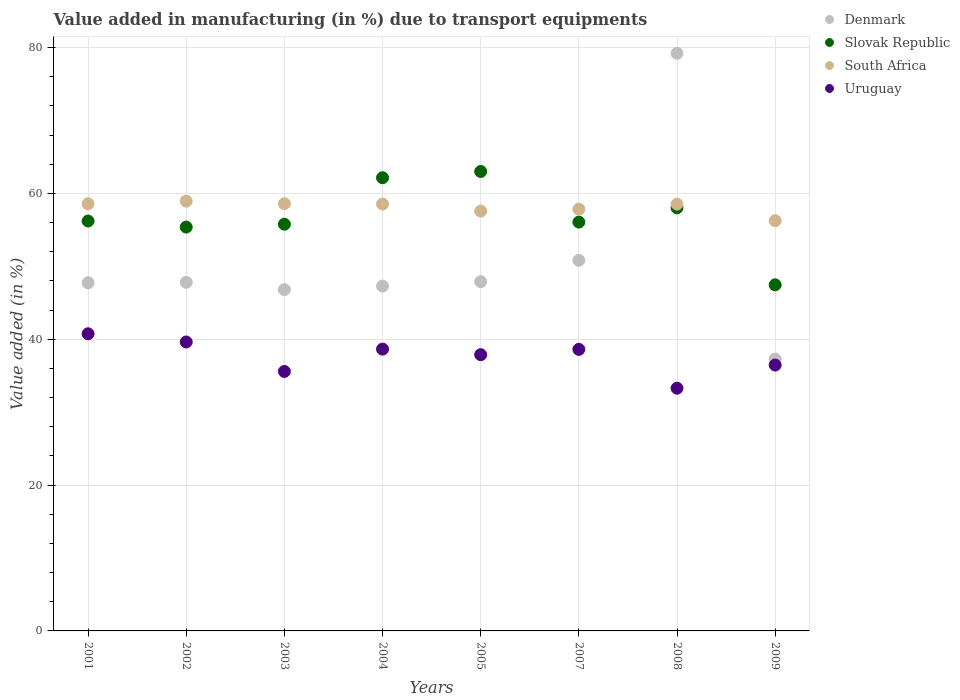What is the percentage of value added in manufacturing due to transport equipments in Denmark in 2007?
Ensure brevity in your answer.  50.82. Across all years, what is the maximum percentage of value added in manufacturing due to transport equipments in Uruguay?
Make the answer very short. 40.75. Across all years, what is the minimum percentage of value added in manufacturing due to transport equipments in South Africa?
Your answer should be compact. 56.25. What is the total percentage of value added in manufacturing due to transport equipments in South Africa in the graph?
Give a very brief answer. 464.84. What is the difference between the percentage of value added in manufacturing due to transport equipments in South Africa in 2005 and that in 2007?
Keep it short and to the point. -0.28. What is the difference between the percentage of value added in manufacturing due to transport equipments in South Africa in 2004 and the percentage of value added in manufacturing due to transport equipments in Uruguay in 2005?
Offer a terse response. 20.66. What is the average percentage of value added in manufacturing due to transport equipments in Denmark per year?
Give a very brief answer. 50.6. In the year 2004, what is the difference between the percentage of value added in manufacturing due to transport equipments in South Africa and percentage of value added in manufacturing due to transport equipments in Uruguay?
Provide a short and direct response. 19.9. What is the ratio of the percentage of value added in manufacturing due to transport equipments in Uruguay in 2008 to that in 2009?
Your response must be concise. 0.91. What is the difference between the highest and the second highest percentage of value added in manufacturing due to transport equipments in Denmark?
Give a very brief answer. 28.39. What is the difference between the highest and the lowest percentage of value added in manufacturing due to transport equipments in South Africa?
Provide a succinct answer. 2.68. Is the sum of the percentage of value added in manufacturing due to transport equipments in Uruguay in 2001 and 2002 greater than the maximum percentage of value added in manufacturing due to transport equipments in Slovak Republic across all years?
Your answer should be compact. Yes. Is it the case that in every year, the sum of the percentage of value added in manufacturing due to transport equipments in Uruguay and percentage of value added in manufacturing due to transport equipments in Denmark  is greater than the percentage of value added in manufacturing due to transport equipments in Slovak Republic?
Make the answer very short. Yes. Does the percentage of value added in manufacturing due to transport equipments in Slovak Republic monotonically increase over the years?
Your response must be concise. No. Is the percentage of value added in manufacturing due to transport equipments in Denmark strictly greater than the percentage of value added in manufacturing due to transport equipments in Slovak Republic over the years?
Make the answer very short. No. Is the percentage of value added in manufacturing due to transport equipments in Slovak Republic strictly less than the percentage of value added in manufacturing due to transport equipments in South Africa over the years?
Make the answer very short. No. How many years are there in the graph?
Offer a terse response. 8. What is the difference between two consecutive major ticks on the Y-axis?
Offer a very short reply. 20. Are the values on the major ticks of Y-axis written in scientific E-notation?
Provide a short and direct response. No. Does the graph contain any zero values?
Your answer should be very brief. No. How many legend labels are there?
Your response must be concise. 4. How are the legend labels stacked?
Your answer should be compact. Vertical. What is the title of the graph?
Your answer should be compact. Value added in manufacturing (in %) due to transport equipments. What is the label or title of the Y-axis?
Your answer should be very brief. Value added (in %). What is the Value added (in %) of Denmark in 2001?
Ensure brevity in your answer.  47.74. What is the Value added (in %) in Slovak Republic in 2001?
Ensure brevity in your answer.  56.21. What is the Value added (in %) of South Africa in 2001?
Your answer should be compact. 58.58. What is the Value added (in %) of Uruguay in 2001?
Your answer should be very brief. 40.75. What is the Value added (in %) of Denmark in 2002?
Give a very brief answer. 47.8. What is the Value added (in %) in Slovak Republic in 2002?
Provide a short and direct response. 55.38. What is the Value added (in %) in South Africa in 2002?
Your response must be concise. 58.93. What is the Value added (in %) of Uruguay in 2002?
Provide a short and direct response. 39.62. What is the Value added (in %) in Denmark in 2003?
Your answer should be compact. 46.8. What is the Value added (in %) of Slovak Republic in 2003?
Keep it short and to the point. 55.77. What is the Value added (in %) of South Africa in 2003?
Your answer should be compact. 58.59. What is the Value added (in %) in Uruguay in 2003?
Give a very brief answer. 35.58. What is the Value added (in %) of Denmark in 2004?
Offer a terse response. 47.29. What is the Value added (in %) in Slovak Republic in 2004?
Keep it short and to the point. 62.15. What is the Value added (in %) of South Africa in 2004?
Make the answer very short. 58.54. What is the Value added (in %) of Uruguay in 2004?
Your answer should be compact. 38.64. What is the Value added (in %) of Denmark in 2005?
Keep it short and to the point. 47.89. What is the Value added (in %) in Slovak Republic in 2005?
Offer a terse response. 63. What is the Value added (in %) of South Africa in 2005?
Keep it short and to the point. 57.57. What is the Value added (in %) in Uruguay in 2005?
Offer a very short reply. 37.88. What is the Value added (in %) in Denmark in 2007?
Ensure brevity in your answer.  50.82. What is the Value added (in %) of Slovak Republic in 2007?
Your answer should be compact. 56.06. What is the Value added (in %) of South Africa in 2007?
Ensure brevity in your answer.  57.85. What is the Value added (in %) in Uruguay in 2007?
Provide a short and direct response. 38.61. What is the Value added (in %) of Denmark in 2008?
Your answer should be very brief. 79.21. What is the Value added (in %) in Slovak Republic in 2008?
Offer a terse response. 58.01. What is the Value added (in %) in South Africa in 2008?
Your answer should be compact. 58.53. What is the Value added (in %) in Uruguay in 2008?
Provide a succinct answer. 33.28. What is the Value added (in %) in Denmark in 2009?
Your answer should be compact. 37.28. What is the Value added (in %) of Slovak Republic in 2009?
Offer a terse response. 47.46. What is the Value added (in %) of South Africa in 2009?
Your answer should be compact. 56.25. What is the Value added (in %) in Uruguay in 2009?
Ensure brevity in your answer.  36.46. Across all years, what is the maximum Value added (in %) of Denmark?
Offer a terse response. 79.21. Across all years, what is the maximum Value added (in %) in Slovak Republic?
Your response must be concise. 63. Across all years, what is the maximum Value added (in %) of South Africa?
Your answer should be very brief. 58.93. Across all years, what is the maximum Value added (in %) in Uruguay?
Your answer should be very brief. 40.75. Across all years, what is the minimum Value added (in %) of Denmark?
Make the answer very short. 37.28. Across all years, what is the minimum Value added (in %) of Slovak Republic?
Your answer should be compact. 47.46. Across all years, what is the minimum Value added (in %) in South Africa?
Ensure brevity in your answer.  56.25. Across all years, what is the minimum Value added (in %) of Uruguay?
Provide a short and direct response. 33.28. What is the total Value added (in %) of Denmark in the graph?
Make the answer very short. 404.83. What is the total Value added (in %) of Slovak Republic in the graph?
Ensure brevity in your answer.  454.04. What is the total Value added (in %) of South Africa in the graph?
Keep it short and to the point. 464.84. What is the total Value added (in %) in Uruguay in the graph?
Ensure brevity in your answer.  300.82. What is the difference between the Value added (in %) of Denmark in 2001 and that in 2002?
Ensure brevity in your answer.  -0.06. What is the difference between the Value added (in %) in Slovak Republic in 2001 and that in 2002?
Offer a terse response. 0.83. What is the difference between the Value added (in %) in South Africa in 2001 and that in 2002?
Your response must be concise. -0.35. What is the difference between the Value added (in %) in Uruguay in 2001 and that in 2002?
Your answer should be very brief. 1.12. What is the difference between the Value added (in %) of Denmark in 2001 and that in 2003?
Provide a short and direct response. 0.94. What is the difference between the Value added (in %) of Slovak Republic in 2001 and that in 2003?
Offer a terse response. 0.44. What is the difference between the Value added (in %) in South Africa in 2001 and that in 2003?
Keep it short and to the point. -0. What is the difference between the Value added (in %) of Uruguay in 2001 and that in 2003?
Make the answer very short. 5.16. What is the difference between the Value added (in %) in Denmark in 2001 and that in 2004?
Ensure brevity in your answer.  0.45. What is the difference between the Value added (in %) in Slovak Republic in 2001 and that in 2004?
Keep it short and to the point. -5.94. What is the difference between the Value added (in %) in South Africa in 2001 and that in 2004?
Provide a short and direct response. 0.04. What is the difference between the Value added (in %) in Uruguay in 2001 and that in 2004?
Give a very brief answer. 2.1. What is the difference between the Value added (in %) of Denmark in 2001 and that in 2005?
Keep it short and to the point. -0.15. What is the difference between the Value added (in %) in Slovak Republic in 2001 and that in 2005?
Provide a succinct answer. -6.79. What is the difference between the Value added (in %) in South Africa in 2001 and that in 2005?
Give a very brief answer. 1.01. What is the difference between the Value added (in %) of Uruguay in 2001 and that in 2005?
Offer a terse response. 2.87. What is the difference between the Value added (in %) in Denmark in 2001 and that in 2007?
Offer a very short reply. -3.08. What is the difference between the Value added (in %) in Slovak Republic in 2001 and that in 2007?
Give a very brief answer. 0.15. What is the difference between the Value added (in %) of South Africa in 2001 and that in 2007?
Your response must be concise. 0.74. What is the difference between the Value added (in %) in Uruguay in 2001 and that in 2007?
Give a very brief answer. 2.14. What is the difference between the Value added (in %) in Denmark in 2001 and that in 2008?
Keep it short and to the point. -31.46. What is the difference between the Value added (in %) of Slovak Republic in 2001 and that in 2008?
Offer a terse response. -1.8. What is the difference between the Value added (in %) of South Africa in 2001 and that in 2008?
Offer a very short reply. 0.05. What is the difference between the Value added (in %) in Uruguay in 2001 and that in 2008?
Your answer should be very brief. 7.46. What is the difference between the Value added (in %) of Denmark in 2001 and that in 2009?
Offer a terse response. 10.46. What is the difference between the Value added (in %) of Slovak Republic in 2001 and that in 2009?
Provide a succinct answer. 8.75. What is the difference between the Value added (in %) in South Africa in 2001 and that in 2009?
Make the answer very short. 2.33. What is the difference between the Value added (in %) in Uruguay in 2001 and that in 2009?
Your response must be concise. 4.29. What is the difference between the Value added (in %) of Slovak Republic in 2002 and that in 2003?
Provide a succinct answer. -0.4. What is the difference between the Value added (in %) of South Africa in 2002 and that in 2003?
Your response must be concise. 0.35. What is the difference between the Value added (in %) in Uruguay in 2002 and that in 2003?
Provide a succinct answer. 4.04. What is the difference between the Value added (in %) of Denmark in 2002 and that in 2004?
Offer a terse response. 0.51. What is the difference between the Value added (in %) in Slovak Republic in 2002 and that in 2004?
Your answer should be very brief. -6.77. What is the difference between the Value added (in %) in South Africa in 2002 and that in 2004?
Your answer should be very brief. 0.39. What is the difference between the Value added (in %) of Uruguay in 2002 and that in 2004?
Keep it short and to the point. 0.98. What is the difference between the Value added (in %) of Denmark in 2002 and that in 2005?
Your answer should be very brief. -0.09. What is the difference between the Value added (in %) in Slovak Republic in 2002 and that in 2005?
Offer a terse response. -7.63. What is the difference between the Value added (in %) of South Africa in 2002 and that in 2005?
Offer a terse response. 1.36. What is the difference between the Value added (in %) of Uruguay in 2002 and that in 2005?
Provide a short and direct response. 1.74. What is the difference between the Value added (in %) of Denmark in 2002 and that in 2007?
Offer a very short reply. -3.02. What is the difference between the Value added (in %) of Slovak Republic in 2002 and that in 2007?
Your response must be concise. -0.69. What is the difference between the Value added (in %) in South Africa in 2002 and that in 2007?
Make the answer very short. 1.09. What is the difference between the Value added (in %) in Uruguay in 2002 and that in 2007?
Offer a terse response. 1.01. What is the difference between the Value added (in %) of Denmark in 2002 and that in 2008?
Provide a succinct answer. -31.4. What is the difference between the Value added (in %) in Slovak Republic in 2002 and that in 2008?
Provide a succinct answer. -2.64. What is the difference between the Value added (in %) in South Africa in 2002 and that in 2008?
Make the answer very short. 0.4. What is the difference between the Value added (in %) in Uruguay in 2002 and that in 2008?
Your response must be concise. 6.34. What is the difference between the Value added (in %) of Denmark in 2002 and that in 2009?
Provide a succinct answer. 10.52. What is the difference between the Value added (in %) in Slovak Republic in 2002 and that in 2009?
Your answer should be very brief. 7.92. What is the difference between the Value added (in %) in South Africa in 2002 and that in 2009?
Provide a short and direct response. 2.68. What is the difference between the Value added (in %) of Uruguay in 2002 and that in 2009?
Give a very brief answer. 3.17. What is the difference between the Value added (in %) of Denmark in 2003 and that in 2004?
Give a very brief answer. -0.49. What is the difference between the Value added (in %) in Slovak Republic in 2003 and that in 2004?
Offer a terse response. -6.37. What is the difference between the Value added (in %) of South Africa in 2003 and that in 2004?
Offer a terse response. 0.05. What is the difference between the Value added (in %) of Uruguay in 2003 and that in 2004?
Keep it short and to the point. -3.06. What is the difference between the Value added (in %) in Denmark in 2003 and that in 2005?
Your answer should be very brief. -1.09. What is the difference between the Value added (in %) in Slovak Republic in 2003 and that in 2005?
Your response must be concise. -7.23. What is the difference between the Value added (in %) of South Africa in 2003 and that in 2005?
Your answer should be compact. 1.02. What is the difference between the Value added (in %) of Uruguay in 2003 and that in 2005?
Keep it short and to the point. -2.3. What is the difference between the Value added (in %) in Denmark in 2003 and that in 2007?
Your answer should be compact. -4.02. What is the difference between the Value added (in %) of Slovak Republic in 2003 and that in 2007?
Your response must be concise. -0.29. What is the difference between the Value added (in %) in South Africa in 2003 and that in 2007?
Provide a succinct answer. 0.74. What is the difference between the Value added (in %) in Uruguay in 2003 and that in 2007?
Your answer should be very brief. -3.03. What is the difference between the Value added (in %) in Denmark in 2003 and that in 2008?
Make the answer very short. -32.4. What is the difference between the Value added (in %) of Slovak Republic in 2003 and that in 2008?
Make the answer very short. -2.24. What is the difference between the Value added (in %) in South Africa in 2003 and that in 2008?
Make the answer very short. 0.06. What is the difference between the Value added (in %) in Uruguay in 2003 and that in 2008?
Provide a short and direct response. 2.3. What is the difference between the Value added (in %) of Denmark in 2003 and that in 2009?
Make the answer very short. 9.52. What is the difference between the Value added (in %) of Slovak Republic in 2003 and that in 2009?
Your answer should be very brief. 8.31. What is the difference between the Value added (in %) of South Africa in 2003 and that in 2009?
Provide a short and direct response. 2.33. What is the difference between the Value added (in %) of Uruguay in 2003 and that in 2009?
Give a very brief answer. -0.87. What is the difference between the Value added (in %) in Denmark in 2004 and that in 2005?
Give a very brief answer. -0.6. What is the difference between the Value added (in %) in Slovak Republic in 2004 and that in 2005?
Give a very brief answer. -0.86. What is the difference between the Value added (in %) in South Africa in 2004 and that in 2005?
Provide a short and direct response. 0.97. What is the difference between the Value added (in %) of Uruguay in 2004 and that in 2005?
Your response must be concise. 0.76. What is the difference between the Value added (in %) of Denmark in 2004 and that in 2007?
Ensure brevity in your answer.  -3.53. What is the difference between the Value added (in %) of Slovak Republic in 2004 and that in 2007?
Keep it short and to the point. 6.08. What is the difference between the Value added (in %) of South Africa in 2004 and that in 2007?
Your answer should be very brief. 0.69. What is the difference between the Value added (in %) in Uruguay in 2004 and that in 2007?
Make the answer very short. 0.03. What is the difference between the Value added (in %) in Denmark in 2004 and that in 2008?
Your answer should be very brief. -31.92. What is the difference between the Value added (in %) in Slovak Republic in 2004 and that in 2008?
Provide a succinct answer. 4.13. What is the difference between the Value added (in %) of South Africa in 2004 and that in 2008?
Ensure brevity in your answer.  0.01. What is the difference between the Value added (in %) of Uruguay in 2004 and that in 2008?
Make the answer very short. 5.36. What is the difference between the Value added (in %) of Denmark in 2004 and that in 2009?
Your answer should be very brief. 10.01. What is the difference between the Value added (in %) in Slovak Republic in 2004 and that in 2009?
Your answer should be compact. 14.69. What is the difference between the Value added (in %) of South Africa in 2004 and that in 2009?
Make the answer very short. 2.29. What is the difference between the Value added (in %) of Uruguay in 2004 and that in 2009?
Ensure brevity in your answer.  2.19. What is the difference between the Value added (in %) of Denmark in 2005 and that in 2007?
Make the answer very short. -2.93. What is the difference between the Value added (in %) of Slovak Republic in 2005 and that in 2007?
Provide a short and direct response. 6.94. What is the difference between the Value added (in %) in South Africa in 2005 and that in 2007?
Provide a succinct answer. -0.28. What is the difference between the Value added (in %) in Uruguay in 2005 and that in 2007?
Your answer should be compact. -0.73. What is the difference between the Value added (in %) of Denmark in 2005 and that in 2008?
Offer a very short reply. -31.31. What is the difference between the Value added (in %) in Slovak Republic in 2005 and that in 2008?
Your response must be concise. 4.99. What is the difference between the Value added (in %) of South Africa in 2005 and that in 2008?
Ensure brevity in your answer.  -0.96. What is the difference between the Value added (in %) of Uruguay in 2005 and that in 2008?
Offer a terse response. 4.6. What is the difference between the Value added (in %) in Denmark in 2005 and that in 2009?
Offer a terse response. 10.61. What is the difference between the Value added (in %) in Slovak Republic in 2005 and that in 2009?
Ensure brevity in your answer.  15.54. What is the difference between the Value added (in %) in South Africa in 2005 and that in 2009?
Ensure brevity in your answer.  1.31. What is the difference between the Value added (in %) in Uruguay in 2005 and that in 2009?
Make the answer very short. 1.42. What is the difference between the Value added (in %) in Denmark in 2007 and that in 2008?
Your response must be concise. -28.39. What is the difference between the Value added (in %) in Slovak Republic in 2007 and that in 2008?
Make the answer very short. -1.95. What is the difference between the Value added (in %) in South Africa in 2007 and that in 2008?
Offer a very short reply. -0.68. What is the difference between the Value added (in %) in Uruguay in 2007 and that in 2008?
Offer a terse response. 5.33. What is the difference between the Value added (in %) of Denmark in 2007 and that in 2009?
Keep it short and to the point. 13.54. What is the difference between the Value added (in %) of Slovak Republic in 2007 and that in 2009?
Keep it short and to the point. 8.6. What is the difference between the Value added (in %) of South Africa in 2007 and that in 2009?
Offer a very short reply. 1.59. What is the difference between the Value added (in %) in Uruguay in 2007 and that in 2009?
Offer a very short reply. 2.15. What is the difference between the Value added (in %) in Denmark in 2008 and that in 2009?
Ensure brevity in your answer.  41.93. What is the difference between the Value added (in %) of Slovak Republic in 2008 and that in 2009?
Your response must be concise. 10.55. What is the difference between the Value added (in %) of South Africa in 2008 and that in 2009?
Provide a succinct answer. 2.28. What is the difference between the Value added (in %) in Uruguay in 2008 and that in 2009?
Your answer should be very brief. -3.17. What is the difference between the Value added (in %) of Denmark in 2001 and the Value added (in %) of Slovak Republic in 2002?
Provide a succinct answer. -7.63. What is the difference between the Value added (in %) in Denmark in 2001 and the Value added (in %) in South Africa in 2002?
Make the answer very short. -11.19. What is the difference between the Value added (in %) of Denmark in 2001 and the Value added (in %) of Uruguay in 2002?
Provide a succinct answer. 8.12. What is the difference between the Value added (in %) of Slovak Republic in 2001 and the Value added (in %) of South Africa in 2002?
Ensure brevity in your answer.  -2.72. What is the difference between the Value added (in %) in Slovak Republic in 2001 and the Value added (in %) in Uruguay in 2002?
Make the answer very short. 16.59. What is the difference between the Value added (in %) in South Africa in 2001 and the Value added (in %) in Uruguay in 2002?
Keep it short and to the point. 18.96. What is the difference between the Value added (in %) of Denmark in 2001 and the Value added (in %) of Slovak Republic in 2003?
Offer a very short reply. -8.03. What is the difference between the Value added (in %) in Denmark in 2001 and the Value added (in %) in South Africa in 2003?
Make the answer very short. -10.84. What is the difference between the Value added (in %) in Denmark in 2001 and the Value added (in %) in Uruguay in 2003?
Make the answer very short. 12.16. What is the difference between the Value added (in %) of Slovak Republic in 2001 and the Value added (in %) of South Africa in 2003?
Keep it short and to the point. -2.38. What is the difference between the Value added (in %) in Slovak Republic in 2001 and the Value added (in %) in Uruguay in 2003?
Your answer should be very brief. 20.63. What is the difference between the Value added (in %) of South Africa in 2001 and the Value added (in %) of Uruguay in 2003?
Keep it short and to the point. 23. What is the difference between the Value added (in %) of Denmark in 2001 and the Value added (in %) of Slovak Republic in 2004?
Give a very brief answer. -14.4. What is the difference between the Value added (in %) of Denmark in 2001 and the Value added (in %) of South Africa in 2004?
Your answer should be very brief. -10.8. What is the difference between the Value added (in %) of Denmark in 2001 and the Value added (in %) of Uruguay in 2004?
Keep it short and to the point. 9.1. What is the difference between the Value added (in %) in Slovak Republic in 2001 and the Value added (in %) in South Africa in 2004?
Keep it short and to the point. -2.33. What is the difference between the Value added (in %) in Slovak Republic in 2001 and the Value added (in %) in Uruguay in 2004?
Your answer should be compact. 17.57. What is the difference between the Value added (in %) in South Africa in 2001 and the Value added (in %) in Uruguay in 2004?
Offer a terse response. 19.94. What is the difference between the Value added (in %) of Denmark in 2001 and the Value added (in %) of Slovak Republic in 2005?
Make the answer very short. -15.26. What is the difference between the Value added (in %) in Denmark in 2001 and the Value added (in %) in South Africa in 2005?
Keep it short and to the point. -9.83. What is the difference between the Value added (in %) in Denmark in 2001 and the Value added (in %) in Uruguay in 2005?
Make the answer very short. 9.86. What is the difference between the Value added (in %) in Slovak Republic in 2001 and the Value added (in %) in South Africa in 2005?
Give a very brief answer. -1.36. What is the difference between the Value added (in %) of Slovak Republic in 2001 and the Value added (in %) of Uruguay in 2005?
Offer a very short reply. 18.33. What is the difference between the Value added (in %) of South Africa in 2001 and the Value added (in %) of Uruguay in 2005?
Make the answer very short. 20.7. What is the difference between the Value added (in %) of Denmark in 2001 and the Value added (in %) of Slovak Republic in 2007?
Give a very brief answer. -8.32. What is the difference between the Value added (in %) of Denmark in 2001 and the Value added (in %) of South Africa in 2007?
Give a very brief answer. -10.1. What is the difference between the Value added (in %) of Denmark in 2001 and the Value added (in %) of Uruguay in 2007?
Provide a short and direct response. 9.13. What is the difference between the Value added (in %) of Slovak Republic in 2001 and the Value added (in %) of South Africa in 2007?
Your response must be concise. -1.64. What is the difference between the Value added (in %) of Slovak Republic in 2001 and the Value added (in %) of Uruguay in 2007?
Ensure brevity in your answer.  17.6. What is the difference between the Value added (in %) of South Africa in 2001 and the Value added (in %) of Uruguay in 2007?
Make the answer very short. 19.97. What is the difference between the Value added (in %) in Denmark in 2001 and the Value added (in %) in Slovak Republic in 2008?
Provide a succinct answer. -10.27. What is the difference between the Value added (in %) in Denmark in 2001 and the Value added (in %) in South Africa in 2008?
Keep it short and to the point. -10.79. What is the difference between the Value added (in %) of Denmark in 2001 and the Value added (in %) of Uruguay in 2008?
Keep it short and to the point. 14.46. What is the difference between the Value added (in %) in Slovak Republic in 2001 and the Value added (in %) in South Africa in 2008?
Provide a succinct answer. -2.32. What is the difference between the Value added (in %) of Slovak Republic in 2001 and the Value added (in %) of Uruguay in 2008?
Ensure brevity in your answer.  22.93. What is the difference between the Value added (in %) of South Africa in 2001 and the Value added (in %) of Uruguay in 2008?
Make the answer very short. 25.3. What is the difference between the Value added (in %) in Denmark in 2001 and the Value added (in %) in Slovak Republic in 2009?
Make the answer very short. 0.28. What is the difference between the Value added (in %) of Denmark in 2001 and the Value added (in %) of South Africa in 2009?
Ensure brevity in your answer.  -8.51. What is the difference between the Value added (in %) of Denmark in 2001 and the Value added (in %) of Uruguay in 2009?
Make the answer very short. 11.29. What is the difference between the Value added (in %) in Slovak Republic in 2001 and the Value added (in %) in South Africa in 2009?
Provide a short and direct response. -0.05. What is the difference between the Value added (in %) in Slovak Republic in 2001 and the Value added (in %) in Uruguay in 2009?
Your response must be concise. 19.75. What is the difference between the Value added (in %) in South Africa in 2001 and the Value added (in %) in Uruguay in 2009?
Offer a very short reply. 22.13. What is the difference between the Value added (in %) of Denmark in 2002 and the Value added (in %) of Slovak Republic in 2003?
Provide a short and direct response. -7.97. What is the difference between the Value added (in %) of Denmark in 2002 and the Value added (in %) of South Africa in 2003?
Provide a short and direct response. -10.78. What is the difference between the Value added (in %) of Denmark in 2002 and the Value added (in %) of Uruguay in 2003?
Provide a succinct answer. 12.22. What is the difference between the Value added (in %) of Slovak Republic in 2002 and the Value added (in %) of South Africa in 2003?
Offer a terse response. -3.21. What is the difference between the Value added (in %) in Slovak Republic in 2002 and the Value added (in %) in Uruguay in 2003?
Offer a very short reply. 19.79. What is the difference between the Value added (in %) of South Africa in 2002 and the Value added (in %) of Uruguay in 2003?
Your response must be concise. 23.35. What is the difference between the Value added (in %) of Denmark in 2002 and the Value added (in %) of Slovak Republic in 2004?
Give a very brief answer. -14.34. What is the difference between the Value added (in %) in Denmark in 2002 and the Value added (in %) in South Africa in 2004?
Your response must be concise. -10.74. What is the difference between the Value added (in %) in Denmark in 2002 and the Value added (in %) in Uruguay in 2004?
Your response must be concise. 9.16. What is the difference between the Value added (in %) of Slovak Republic in 2002 and the Value added (in %) of South Africa in 2004?
Make the answer very short. -3.16. What is the difference between the Value added (in %) in Slovak Republic in 2002 and the Value added (in %) in Uruguay in 2004?
Provide a short and direct response. 16.73. What is the difference between the Value added (in %) in South Africa in 2002 and the Value added (in %) in Uruguay in 2004?
Your answer should be very brief. 20.29. What is the difference between the Value added (in %) in Denmark in 2002 and the Value added (in %) in Slovak Republic in 2005?
Give a very brief answer. -15.2. What is the difference between the Value added (in %) in Denmark in 2002 and the Value added (in %) in South Africa in 2005?
Your answer should be compact. -9.77. What is the difference between the Value added (in %) of Denmark in 2002 and the Value added (in %) of Uruguay in 2005?
Ensure brevity in your answer.  9.92. What is the difference between the Value added (in %) of Slovak Republic in 2002 and the Value added (in %) of South Africa in 2005?
Ensure brevity in your answer.  -2.19. What is the difference between the Value added (in %) of Slovak Republic in 2002 and the Value added (in %) of Uruguay in 2005?
Your response must be concise. 17.5. What is the difference between the Value added (in %) in South Africa in 2002 and the Value added (in %) in Uruguay in 2005?
Give a very brief answer. 21.05. What is the difference between the Value added (in %) of Denmark in 2002 and the Value added (in %) of Slovak Republic in 2007?
Your response must be concise. -8.26. What is the difference between the Value added (in %) of Denmark in 2002 and the Value added (in %) of South Africa in 2007?
Offer a terse response. -10.04. What is the difference between the Value added (in %) in Denmark in 2002 and the Value added (in %) in Uruguay in 2007?
Offer a very short reply. 9.19. What is the difference between the Value added (in %) in Slovak Republic in 2002 and the Value added (in %) in South Africa in 2007?
Provide a succinct answer. -2.47. What is the difference between the Value added (in %) in Slovak Republic in 2002 and the Value added (in %) in Uruguay in 2007?
Your answer should be very brief. 16.77. What is the difference between the Value added (in %) in South Africa in 2002 and the Value added (in %) in Uruguay in 2007?
Give a very brief answer. 20.32. What is the difference between the Value added (in %) in Denmark in 2002 and the Value added (in %) in Slovak Republic in 2008?
Your answer should be compact. -10.21. What is the difference between the Value added (in %) in Denmark in 2002 and the Value added (in %) in South Africa in 2008?
Offer a terse response. -10.73. What is the difference between the Value added (in %) in Denmark in 2002 and the Value added (in %) in Uruguay in 2008?
Ensure brevity in your answer.  14.52. What is the difference between the Value added (in %) of Slovak Republic in 2002 and the Value added (in %) of South Africa in 2008?
Make the answer very short. -3.15. What is the difference between the Value added (in %) in Slovak Republic in 2002 and the Value added (in %) in Uruguay in 2008?
Ensure brevity in your answer.  22.09. What is the difference between the Value added (in %) of South Africa in 2002 and the Value added (in %) of Uruguay in 2008?
Offer a terse response. 25.65. What is the difference between the Value added (in %) in Denmark in 2002 and the Value added (in %) in Slovak Republic in 2009?
Keep it short and to the point. 0.34. What is the difference between the Value added (in %) in Denmark in 2002 and the Value added (in %) in South Africa in 2009?
Ensure brevity in your answer.  -8.45. What is the difference between the Value added (in %) in Denmark in 2002 and the Value added (in %) in Uruguay in 2009?
Ensure brevity in your answer.  11.35. What is the difference between the Value added (in %) in Slovak Republic in 2002 and the Value added (in %) in South Africa in 2009?
Your response must be concise. -0.88. What is the difference between the Value added (in %) in Slovak Republic in 2002 and the Value added (in %) in Uruguay in 2009?
Your response must be concise. 18.92. What is the difference between the Value added (in %) of South Africa in 2002 and the Value added (in %) of Uruguay in 2009?
Offer a terse response. 22.48. What is the difference between the Value added (in %) of Denmark in 2003 and the Value added (in %) of Slovak Republic in 2004?
Keep it short and to the point. -15.34. What is the difference between the Value added (in %) in Denmark in 2003 and the Value added (in %) in South Africa in 2004?
Your answer should be compact. -11.74. What is the difference between the Value added (in %) of Denmark in 2003 and the Value added (in %) of Uruguay in 2004?
Provide a succinct answer. 8.16. What is the difference between the Value added (in %) in Slovak Republic in 2003 and the Value added (in %) in South Africa in 2004?
Your response must be concise. -2.77. What is the difference between the Value added (in %) in Slovak Republic in 2003 and the Value added (in %) in Uruguay in 2004?
Your response must be concise. 17.13. What is the difference between the Value added (in %) in South Africa in 2003 and the Value added (in %) in Uruguay in 2004?
Offer a terse response. 19.94. What is the difference between the Value added (in %) in Denmark in 2003 and the Value added (in %) in Slovak Republic in 2005?
Your response must be concise. -16.2. What is the difference between the Value added (in %) in Denmark in 2003 and the Value added (in %) in South Africa in 2005?
Ensure brevity in your answer.  -10.77. What is the difference between the Value added (in %) in Denmark in 2003 and the Value added (in %) in Uruguay in 2005?
Provide a short and direct response. 8.92. What is the difference between the Value added (in %) of Slovak Republic in 2003 and the Value added (in %) of South Africa in 2005?
Provide a succinct answer. -1.8. What is the difference between the Value added (in %) in Slovak Republic in 2003 and the Value added (in %) in Uruguay in 2005?
Offer a terse response. 17.89. What is the difference between the Value added (in %) of South Africa in 2003 and the Value added (in %) of Uruguay in 2005?
Make the answer very short. 20.71. What is the difference between the Value added (in %) of Denmark in 2003 and the Value added (in %) of Slovak Republic in 2007?
Provide a succinct answer. -9.26. What is the difference between the Value added (in %) in Denmark in 2003 and the Value added (in %) in South Africa in 2007?
Your response must be concise. -11.04. What is the difference between the Value added (in %) in Denmark in 2003 and the Value added (in %) in Uruguay in 2007?
Your response must be concise. 8.19. What is the difference between the Value added (in %) in Slovak Republic in 2003 and the Value added (in %) in South Africa in 2007?
Offer a terse response. -2.08. What is the difference between the Value added (in %) of Slovak Republic in 2003 and the Value added (in %) of Uruguay in 2007?
Provide a succinct answer. 17.16. What is the difference between the Value added (in %) in South Africa in 2003 and the Value added (in %) in Uruguay in 2007?
Your response must be concise. 19.98. What is the difference between the Value added (in %) in Denmark in 2003 and the Value added (in %) in Slovak Republic in 2008?
Offer a very short reply. -11.21. What is the difference between the Value added (in %) in Denmark in 2003 and the Value added (in %) in South Africa in 2008?
Give a very brief answer. -11.73. What is the difference between the Value added (in %) in Denmark in 2003 and the Value added (in %) in Uruguay in 2008?
Provide a succinct answer. 13.52. What is the difference between the Value added (in %) in Slovak Republic in 2003 and the Value added (in %) in South Africa in 2008?
Provide a short and direct response. -2.76. What is the difference between the Value added (in %) of Slovak Republic in 2003 and the Value added (in %) of Uruguay in 2008?
Give a very brief answer. 22.49. What is the difference between the Value added (in %) of South Africa in 2003 and the Value added (in %) of Uruguay in 2008?
Your answer should be compact. 25.3. What is the difference between the Value added (in %) of Denmark in 2003 and the Value added (in %) of Slovak Republic in 2009?
Keep it short and to the point. -0.66. What is the difference between the Value added (in %) of Denmark in 2003 and the Value added (in %) of South Africa in 2009?
Give a very brief answer. -9.45. What is the difference between the Value added (in %) in Denmark in 2003 and the Value added (in %) in Uruguay in 2009?
Provide a succinct answer. 10.35. What is the difference between the Value added (in %) of Slovak Republic in 2003 and the Value added (in %) of South Africa in 2009?
Keep it short and to the point. -0.48. What is the difference between the Value added (in %) of Slovak Republic in 2003 and the Value added (in %) of Uruguay in 2009?
Ensure brevity in your answer.  19.32. What is the difference between the Value added (in %) in South Africa in 2003 and the Value added (in %) in Uruguay in 2009?
Provide a succinct answer. 22.13. What is the difference between the Value added (in %) in Denmark in 2004 and the Value added (in %) in Slovak Republic in 2005?
Offer a terse response. -15.72. What is the difference between the Value added (in %) in Denmark in 2004 and the Value added (in %) in South Africa in 2005?
Your response must be concise. -10.28. What is the difference between the Value added (in %) in Denmark in 2004 and the Value added (in %) in Uruguay in 2005?
Offer a terse response. 9.41. What is the difference between the Value added (in %) of Slovak Republic in 2004 and the Value added (in %) of South Africa in 2005?
Your answer should be compact. 4.58. What is the difference between the Value added (in %) in Slovak Republic in 2004 and the Value added (in %) in Uruguay in 2005?
Provide a short and direct response. 24.27. What is the difference between the Value added (in %) of South Africa in 2004 and the Value added (in %) of Uruguay in 2005?
Your answer should be compact. 20.66. What is the difference between the Value added (in %) in Denmark in 2004 and the Value added (in %) in Slovak Republic in 2007?
Give a very brief answer. -8.78. What is the difference between the Value added (in %) in Denmark in 2004 and the Value added (in %) in South Africa in 2007?
Your answer should be very brief. -10.56. What is the difference between the Value added (in %) in Denmark in 2004 and the Value added (in %) in Uruguay in 2007?
Your response must be concise. 8.68. What is the difference between the Value added (in %) in Slovak Republic in 2004 and the Value added (in %) in South Africa in 2007?
Ensure brevity in your answer.  4.3. What is the difference between the Value added (in %) in Slovak Republic in 2004 and the Value added (in %) in Uruguay in 2007?
Ensure brevity in your answer.  23.54. What is the difference between the Value added (in %) of South Africa in 2004 and the Value added (in %) of Uruguay in 2007?
Offer a very short reply. 19.93. What is the difference between the Value added (in %) in Denmark in 2004 and the Value added (in %) in Slovak Republic in 2008?
Keep it short and to the point. -10.73. What is the difference between the Value added (in %) of Denmark in 2004 and the Value added (in %) of South Africa in 2008?
Offer a very short reply. -11.24. What is the difference between the Value added (in %) in Denmark in 2004 and the Value added (in %) in Uruguay in 2008?
Make the answer very short. 14.01. What is the difference between the Value added (in %) of Slovak Republic in 2004 and the Value added (in %) of South Africa in 2008?
Offer a very short reply. 3.62. What is the difference between the Value added (in %) in Slovak Republic in 2004 and the Value added (in %) in Uruguay in 2008?
Your response must be concise. 28.86. What is the difference between the Value added (in %) of South Africa in 2004 and the Value added (in %) of Uruguay in 2008?
Your answer should be very brief. 25.26. What is the difference between the Value added (in %) of Denmark in 2004 and the Value added (in %) of Slovak Republic in 2009?
Make the answer very short. -0.17. What is the difference between the Value added (in %) of Denmark in 2004 and the Value added (in %) of South Africa in 2009?
Ensure brevity in your answer.  -8.97. What is the difference between the Value added (in %) in Denmark in 2004 and the Value added (in %) in Uruguay in 2009?
Your answer should be compact. 10.83. What is the difference between the Value added (in %) in Slovak Republic in 2004 and the Value added (in %) in South Africa in 2009?
Your answer should be compact. 5.89. What is the difference between the Value added (in %) in Slovak Republic in 2004 and the Value added (in %) in Uruguay in 2009?
Offer a very short reply. 25.69. What is the difference between the Value added (in %) in South Africa in 2004 and the Value added (in %) in Uruguay in 2009?
Keep it short and to the point. 22.08. What is the difference between the Value added (in %) of Denmark in 2005 and the Value added (in %) of Slovak Republic in 2007?
Keep it short and to the point. -8.17. What is the difference between the Value added (in %) of Denmark in 2005 and the Value added (in %) of South Africa in 2007?
Make the answer very short. -9.95. What is the difference between the Value added (in %) of Denmark in 2005 and the Value added (in %) of Uruguay in 2007?
Give a very brief answer. 9.28. What is the difference between the Value added (in %) in Slovak Republic in 2005 and the Value added (in %) in South Africa in 2007?
Your response must be concise. 5.16. What is the difference between the Value added (in %) in Slovak Republic in 2005 and the Value added (in %) in Uruguay in 2007?
Your answer should be compact. 24.39. What is the difference between the Value added (in %) of South Africa in 2005 and the Value added (in %) of Uruguay in 2007?
Your answer should be compact. 18.96. What is the difference between the Value added (in %) in Denmark in 2005 and the Value added (in %) in Slovak Republic in 2008?
Provide a succinct answer. -10.12. What is the difference between the Value added (in %) in Denmark in 2005 and the Value added (in %) in South Africa in 2008?
Keep it short and to the point. -10.64. What is the difference between the Value added (in %) in Denmark in 2005 and the Value added (in %) in Uruguay in 2008?
Ensure brevity in your answer.  14.61. What is the difference between the Value added (in %) in Slovak Republic in 2005 and the Value added (in %) in South Africa in 2008?
Offer a terse response. 4.47. What is the difference between the Value added (in %) in Slovak Republic in 2005 and the Value added (in %) in Uruguay in 2008?
Keep it short and to the point. 29.72. What is the difference between the Value added (in %) in South Africa in 2005 and the Value added (in %) in Uruguay in 2008?
Keep it short and to the point. 24.29. What is the difference between the Value added (in %) of Denmark in 2005 and the Value added (in %) of Slovak Republic in 2009?
Provide a short and direct response. 0.43. What is the difference between the Value added (in %) in Denmark in 2005 and the Value added (in %) in South Africa in 2009?
Provide a succinct answer. -8.36. What is the difference between the Value added (in %) of Denmark in 2005 and the Value added (in %) of Uruguay in 2009?
Provide a succinct answer. 11.44. What is the difference between the Value added (in %) in Slovak Republic in 2005 and the Value added (in %) in South Africa in 2009?
Offer a very short reply. 6.75. What is the difference between the Value added (in %) in Slovak Republic in 2005 and the Value added (in %) in Uruguay in 2009?
Offer a very short reply. 26.55. What is the difference between the Value added (in %) of South Africa in 2005 and the Value added (in %) of Uruguay in 2009?
Offer a terse response. 21.11. What is the difference between the Value added (in %) of Denmark in 2007 and the Value added (in %) of Slovak Republic in 2008?
Provide a short and direct response. -7.2. What is the difference between the Value added (in %) of Denmark in 2007 and the Value added (in %) of South Africa in 2008?
Your answer should be very brief. -7.71. What is the difference between the Value added (in %) of Denmark in 2007 and the Value added (in %) of Uruguay in 2008?
Offer a terse response. 17.54. What is the difference between the Value added (in %) in Slovak Republic in 2007 and the Value added (in %) in South Africa in 2008?
Provide a succinct answer. -2.47. What is the difference between the Value added (in %) in Slovak Republic in 2007 and the Value added (in %) in Uruguay in 2008?
Ensure brevity in your answer.  22.78. What is the difference between the Value added (in %) of South Africa in 2007 and the Value added (in %) of Uruguay in 2008?
Your response must be concise. 24.56. What is the difference between the Value added (in %) in Denmark in 2007 and the Value added (in %) in Slovak Republic in 2009?
Your answer should be very brief. 3.36. What is the difference between the Value added (in %) in Denmark in 2007 and the Value added (in %) in South Africa in 2009?
Ensure brevity in your answer.  -5.44. What is the difference between the Value added (in %) in Denmark in 2007 and the Value added (in %) in Uruguay in 2009?
Your answer should be very brief. 14.36. What is the difference between the Value added (in %) in Slovak Republic in 2007 and the Value added (in %) in South Africa in 2009?
Ensure brevity in your answer.  -0.19. What is the difference between the Value added (in %) of Slovak Republic in 2007 and the Value added (in %) of Uruguay in 2009?
Your answer should be compact. 19.61. What is the difference between the Value added (in %) of South Africa in 2007 and the Value added (in %) of Uruguay in 2009?
Offer a very short reply. 21.39. What is the difference between the Value added (in %) of Denmark in 2008 and the Value added (in %) of Slovak Republic in 2009?
Provide a short and direct response. 31.75. What is the difference between the Value added (in %) in Denmark in 2008 and the Value added (in %) in South Africa in 2009?
Make the answer very short. 22.95. What is the difference between the Value added (in %) of Denmark in 2008 and the Value added (in %) of Uruguay in 2009?
Offer a terse response. 42.75. What is the difference between the Value added (in %) in Slovak Republic in 2008 and the Value added (in %) in South Africa in 2009?
Offer a very short reply. 1.76. What is the difference between the Value added (in %) of Slovak Republic in 2008 and the Value added (in %) of Uruguay in 2009?
Make the answer very short. 21.56. What is the difference between the Value added (in %) of South Africa in 2008 and the Value added (in %) of Uruguay in 2009?
Offer a terse response. 22.07. What is the average Value added (in %) in Denmark per year?
Ensure brevity in your answer.  50.6. What is the average Value added (in %) of Slovak Republic per year?
Provide a short and direct response. 56.76. What is the average Value added (in %) in South Africa per year?
Offer a very short reply. 58.11. What is the average Value added (in %) of Uruguay per year?
Your answer should be compact. 37.6. In the year 2001, what is the difference between the Value added (in %) of Denmark and Value added (in %) of Slovak Republic?
Ensure brevity in your answer.  -8.47. In the year 2001, what is the difference between the Value added (in %) in Denmark and Value added (in %) in South Africa?
Provide a short and direct response. -10.84. In the year 2001, what is the difference between the Value added (in %) of Denmark and Value added (in %) of Uruguay?
Offer a terse response. 7. In the year 2001, what is the difference between the Value added (in %) in Slovak Republic and Value added (in %) in South Africa?
Give a very brief answer. -2.38. In the year 2001, what is the difference between the Value added (in %) in Slovak Republic and Value added (in %) in Uruguay?
Your answer should be compact. 15.46. In the year 2001, what is the difference between the Value added (in %) of South Africa and Value added (in %) of Uruguay?
Your answer should be compact. 17.84. In the year 2002, what is the difference between the Value added (in %) in Denmark and Value added (in %) in Slovak Republic?
Your answer should be very brief. -7.57. In the year 2002, what is the difference between the Value added (in %) of Denmark and Value added (in %) of South Africa?
Offer a terse response. -11.13. In the year 2002, what is the difference between the Value added (in %) in Denmark and Value added (in %) in Uruguay?
Offer a very short reply. 8.18. In the year 2002, what is the difference between the Value added (in %) of Slovak Republic and Value added (in %) of South Africa?
Your response must be concise. -3.56. In the year 2002, what is the difference between the Value added (in %) of Slovak Republic and Value added (in %) of Uruguay?
Make the answer very short. 15.75. In the year 2002, what is the difference between the Value added (in %) of South Africa and Value added (in %) of Uruguay?
Give a very brief answer. 19.31. In the year 2003, what is the difference between the Value added (in %) of Denmark and Value added (in %) of Slovak Republic?
Give a very brief answer. -8.97. In the year 2003, what is the difference between the Value added (in %) in Denmark and Value added (in %) in South Africa?
Make the answer very short. -11.78. In the year 2003, what is the difference between the Value added (in %) of Denmark and Value added (in %) of Uruguay?
Give a very brief answer. 11.22. In the year 2003, what is the difference between the Value added (in %) in Slovak Republic and Value added (in %) in South Africa?
Your answer should be compact. -2.82. In the year 2003, what is the difference between the Value added (in %) in Slovak Republic and Value added (in %) in Uruguay?
Offer a terse response. 20.19. In the year 2003, what is the difference between the Value added (in %) in South Africa and Value added (in %) in Uruguay?
Your answer should be very brief. 23. In the year 2004, what is the difference between the Value added (in %) in Denmark and Value added (in %) in Slovak Republic?
Offer a terse response. -14.86. In the year 2004, what is the difference between the Value added (in %) of Denmark and Value added (in %) of South Africa?
Provide a short and direct response. -11.25. In the year 2004, what is the difference between the Value added (in %) of Denmark and Value added (in %) of Uruguay?
Your response must be concise. 8.64. In the year 2004, what is the difference between the Value added (in %) in Slovak Republic and Value added (in %) in South Africa?
Your response must be concise. 3.61. In the year 2004, what is the difference between the Value added (in %) in Slovak Republic and Value added (in %) in Uruguay?
Ensure brevity in your answer.  23.5. In the year 2004, what is the difference between the Value added (in %) in South Africa and Value added (in %) in Uruguay?
Make the answer very short. 19.9. In the year 2005, what is the difference between the Value added (in %) in Denmark and Value added (in %) in Slovak Republic?
Give a very brief answer. -15.11. In the year 2005, what is the difference between the Value added (in %) in Denmark and Value added (in %) in South Africa?
Keep it short and to the point. -9.68. In the year 2005, what is the difference between the Value added (in %) in Denmark and Value added (in %) in Uruguay?
Your answer should be very brief. 10.01. In the year 2005, what is the difference between the Value added (in %) in Slovak Republic and Value added (in %) in South Africa?
Keep it short and to the point. 5.43. In the year 2005, what is the difference between the Value added (in %) of Slovak Republic and Value added (in %) of Uruguay?
Provide a succinct answer. 25.12. In the year 2005, what is the difference between the Value added (in %) in South Africa and Value added (in %) in Uruguay?
Keep it short and to the point. 19.69. In the year 2007, what is the difference between the Value added (in %) in Denmark and Value added (in %) in Slovak Republic?
Offer a terse response. -5.25. In the year 2007, what is the difference between the Value added (in %) in Denmark and Value added (in %) in South Africa?
Give a very brief answer. -7.03. In the year 2007, what is the difference between the Value added (in %) of Denmark and Value added (in %) of Uruguay?
Your answer should be very brief. 12.21. In the year 2007, what is the difference between the Value added (in %) of Slovak Republic and Value added (in %) of South Africa?
Your answer should be compact. -1.78. In the year 2007, what is the difference between the Value added (in %) of Slovak Republic and Value added (in %) of Uruguay?
Offer a terse response. 17.45. In the year 2007, what is the difference between the Value added (in %) in South Africa and Value added (in %) in Uruguay?
Give a very brief answer. 19.24. In the year 2008, what is the difference between the Value added (in %) of Denmark and Value added (in %) of Slovak Republic?
Provide a succinct answer. 21.19. In the year 2008, what is the difference between the Value added (in %) of Denmark and Value added (in %) of South Africa?
Give a very brief answer. 20.68. In the year 2008, what is the difference between the Value added (in %) of Denmark and Value added (in %) of Uruguay?
Provide a short and direct response. 45.92. In the year 2008, what is the difference between the Value added (in %) in Slovak Republic and Value added (in %) in South Africa?
Your answer should be very brief. -0.52. In the year 2008, what is the difference between the Value added (in %) in Slovak Republic and Value added (in %) in Uruguay?
Your answer should be very brief. 24.73. In the year 2008, what is the difference between the Value added (in %) in South Africa and Value added (in %) in Uruguay?
Your answer should be very brief. 25.25. In the year 2009, what is the difference between the Value added (in %) in Denmark and Value added (in %) in Slovak Republic?
Keep it short and to the point. -10.18. In the year 2009, what is the difference between the Value added (in %) of Denmark and Value added (in %) of South Africa?
Give a very brief answer. -18.98. In the year 2009, what is the difference between the Value added (in %) of Denmark and Value added (in %) of Uruguay?
Offer a terse response. 0.82. In the year 2009, what is the difference between the Value added (in %) of Slovak Republic and Value added (in %) of South Africa?
Offer a very short reply. -8.79. In the year 2009, what is the difference between the Value added (in %) of Slovak Republic and Value added (in %) of Uruguay?
Ensure brevity in your answer.  11. In the year 2009, what is the difference between the Value added (in %) in South Africa and Value added (in %) in Uruguay?
Make the answer very short. 19.8. What is the ratio of the Value added (in %) in Slovak Republic in 2001 to that in 2002?
Your answer should be compact. 1.01. What is the ratio of the Value added (in %) in South Africa in 2001 to that in 2002?
Your answer should be compact. 0.99. What is the ratio of the Value added (in %) in Uruguay in 2001 to that in 2002?
Give a very brief answer. 1.03. What is the ratio of the Value added (in %) of Denmark in 2001 to that in 2003?
Your answer should be very brief. 1.02. What is the ratio of the Value added (in %) in South Africa in 2001 to that in 2003?
Offer a terse response. 1. What is the ratio of the Value added (in %) of Uruguay in 2001 to that in 2003?
Ensure brevity in your answer.  1.15. What is the ratio of the Value added (in %) in Denmark in 2001 to that in 2004?
Your answer should be compact. 1.01. What is the ratio of the Value added (in %) in Slovak Republic in 2001 to that in 2004?
Offer a very short reply. 0.9. What is the ratio of the Value added (in %) of South Africa in 2001 to that in 2004?
Provide a short and direct response. 1. What is the ratio of the Value added (in %) of Uruguay in 2001 to that in 2004?
Provide a succinct answer. 1.05. What is the ratio of the Value added (in %) of Slovak Republic in 2001 to that in 2005?
Your answer should be compact. 0.89. What is the ratio of the Value added (in %) in South Africa in 2001 to that in 2005?
Offer a very short reply. 1.02. What is the ratio of the Value added (in %) of Uruguay in 2001 to that in 2005?
Make the answer very short. 1.08. What is the ratio of the Value added (in %) in Denmark in 2001 to that in 2007?
Provide a short and direct response. 0.94. What is the ratio of the Value added (in %) in Slovak Republic in 2001 to that in 2007?
Your response must be concise. 1. What is the ratio of the Value added (in %) of South Africa in 2001 to that in 2007?
Keep it short and to the point. 1.01. What is the ratio of the Value added (in %) of Uruguay in 2001 to that in 2007?
Ensure brevity in your answer.  1.06. What is the ratio of the Value added (in %) in Denmark in 2001 to that in 2008?
Make the answer very short. 0.6. What is the ratio of the Value added (in %) of Slovak Republic in 2001 to that in 2008?
Your response must be concise. 0.97. What is the ratio of the Value added (in %) in South Africa in 2001 to that in 2008?
Your answer should be compact. 1. What is the ratio of the Value added (in %) in Uruguay in 2001 to that in 2008?
Your response must be concise. 1.22. What is the ratio of the Value added (in %) in Denmark in 2001 to that in 2009?
Your answer should be very brief. 1.28. What is the ratio of the Value added (in %) of Slovak Republic in 2001 to that in 2009?
Your answer should be very brief. 1.18. What is the ratio of the Value added (in %) in South Africa in 2001 to that in 2009?
Ensure brevity in your answer.  1.04. What is the ratio of the Value added (in %) of Uruguay in 2001 to that in 2009?
Keep it short and to the point. 1.12. What is the ratio of the Value added (in %) in Denmark in 2002 to that in 2003?
Provide a short and direct response. 1.02. What is the ratio of the Value added (in %) of Slovak Republic in 2002 to that in 2003?
Your answer should be very brief. 0.99. What is the ratio of the Value added (in %) in South Africa in 2002 to that in 2003?
Ensure brevity in your answer.  1.01. What is the ratio of the Value added (in %) in Uruguay in 2002 to that in 2003?
Provide a short and direct response. 1.11. What is the ratio of the Value added (in %) of Denmark in 2002 to that in 2004?
Give a very brief answer. 1.01. What is the ratio of the Value added (in %) in Slovak Republic in 2002 to that in 2004?
Make the answer very short. 0.89. What is the ratio of the Value added (in %) in South Africa in 2002 to that in 2004?
Your answer should be compact. 1.01. What is the ratio of the Value added (in %) in Uruguay in 2002 to that in 2004?
Your response must be concise. 1.03. What is the ratio of the Value added (in %) of Denmark in 2002 to that in 2005?
Ensure brevity in your answer.  1. What is the ratio of the Value added (in %) in Slovak Republic in 2002 to that in 2005?
Provide a short and direct response. 0.88. What is the ratio of the Value added (in %) of South Africa in 2002 to that in 2005?
Offer a very short reply. 1.02. What is the ratio of the Value added (in %) in Uruguay in 2002 to that in 2005?
Your response must be concise. 1.05. What is the ratio of the Value added (in %) of Denmark in 2002 to that in 2007?
Give a very brief answer. 0.94. What is the ratio of the Value added (in %) in Slovak Republic in 2002 to that in 2007?
Provide a short and direct response. 0.99. What is the ratio of the Value added (in %) of South Africa in 2002 to that in 2007?
Your response must be concise. 1.02. What is the ratio of the Value added (in %) of Uruguay in 2002 to that in 2007?
Make the answer very short. 1.03. What is the ratio of the Value added (in %) in Denmark in 2002 to that in 2008?
Your answer should be very brief. 0.6. What is the ratio of the Value added (in %) of Slovak Republic in 2002 to that in 2008?
Your answer should be very brief. 0.95. What is the ratio of the Value added (in %) of South Africa in 2002 to that in 2008?
Provide a short and direct response. 1.01. What is the ratio of the Value added (in %) of Uruguay in 2002 to that in 2008?
Offer a very short reply. 1.19. What is the ratio of the Value added (in %) of Denmark in 2002 to that in 2009?
Offer a very short reply. 1.28. What is the ratio of the Value added (in %) in Slovak Republic in 2002 to that in 2009?
Give a very brief answer. 1.17. What is the ratio of the Value added (in %) in South Africa in 2002 to that in 2009?
Your answer should be very brief. 1.05. What is the ratio of the Value added (in %) of Uruguay in 2002 to that in 2009?
Your response must be concise. 1.09. What is the ratio of the Value added (in %) of Denmark in 2003 to that in 2004?
Offer a very short reply. 0.99. What is the ratio of the Value added (in %) of Slovak Republic in 2003 to that in 2004?
Ensure brevity in your answer.  0.9. What is the ratio of the Value added (in %) in Uruguay in 2003 to that in 2004?
Offer a very short reply. 0.92. What is the ratio of the Value added (in %) in Denmark in 2003 to that in 2005?
Your response must be concise. 0.98. What is the ratio of the Value added (in %) of Slovak Republic in 2003 to that in 2005?
Make the answer very short. 0.89. What is the ratio of the Value added (in %) in South Africa in 2003 to that in 2005?
Make the answer very short. 1.02. What is the ratio of the Value added (in %) in Uruguay in 2003 to that in 2005?
Offer a very short reply. 0.94. What is the ratio of the Value added (in %) of Denmark in 2003 to that in 2007?
Provide a short and direct response. 0.92. What is the ratio of the Value added (in %) of Slovak Republic in 2003 to that in 2007?
Your response must be concise. 0.99. What is the ratio of the Value added (in %) of South Africa in 2003 to that in 2007?
Your answer should be compact. 1.01. What is the ratio of the Value added (in %) in Uruguay in 2003 to that in 2007?
Give a very brief answer. 0.92. What is the ratio of the Value added (in %) in Denmark in 2003 to that in 2008?
Ensure brevity in your answer.  0.59. What is the ratio of the Value added (in %) in Slovak Republic in 2003 to that in 2008?
Your response must be concise. 0.96. What is the ratio of the Value added (in %) in South Africa in 2003 to that in 2008?
Your answer should be compact. 1. What is the ratio of the Value added (in %) in Uruguay in 2003 to that in 2008?
Your answer should be compact. 1.07. What is the ratio of the Value added (in %) of Denmark in 2003 to that in 2009?
Keep it short and to the point. 1.26. What is the ratio of the Value added (in %) in Slovak Republic in 2003 to that in 2009?
Your answer should be very brief. 1.18. What is the ratio of the Value added (in %) in South Africa in 2003 to that in 2009?
Keep it short and to the point. 1.04. What is the ratio of the Value added (in %) in Uruguay in 2003 to that in 2009?
Provide a succinct answer. 0.98. What is the ratio of the Value added (in %) of Denmark in 2004 to that in 2005?
Your answer should be very brief. 0.99. What is the ratio of the Value added (in %) of Slovak Republic in 2004 to that in 2005?
Ensure brevity in your answer.  0.99. What is the ratio of the Value added (in %) in South Africa in 2004 to that in 2005?
Offer a terse response. 1.02. What is the ratio of the Value added (in %) of Uruguay in 2004 to that in 2005?
Give a very brief answer. 1.02. What is the ratio of the Value added (in %) of Denmark in 2004 to that in 2007?
Provide a succinct answer. 0.93. What is the ratio of the Value added (in %) of Slovak Republic in 2004 to that in 2007?
Provide a short and direct response. 1.11. What is the ratio of the Value added (in %) in South Africa in 2004 to that in 2007?
Provide a short and direct response. 1.01. What is the ratio of the Value added (in %) of Denmark in 2004 to that in 2008?
Offer a very short reply. 0.6. What is the ratio of the Value added (in %) of Slovak Republic in 2004 to that in 2008?
Provide a short and direct response. 1.07. What is the ratio of the Value added (in %) in Uruguay in 2004 to that in 2008?
Provide a succinct answer. 1.16. What is the ratio of the Value added (in %) in Denmark in 2004 to that in 2009?
Make the answer very short. 1.27. What is the ratio of the Value added (in %) of Slovak Republic in 2004 to that in 2009?
Ensure brevity in your answer.  1.31. What is the ratio of the Value added (in %) of South Africa in 2004 to that in 2009?
Make the answer very short. 1.04. What is the ratio of the Value added (in %) in Uruguay in 2004 to that in 2009?
Your answer should be compact. 1.06. What is the ratio of the Value added (in %) in Denmark in 2005 to that in 2007?
Offer a terse response. 0.94. What is the ratio of the Value added (in %) of Slovak Republic in 2005 to that in 2007?
Give a very brief answer. 1.12. What is the ratio of the Value added (in %) of Uruguay in 2005 to that in 2007?
Offer a terse response. 0.98. What is the ratio of the Value added (in %) in Denmark in 2005 to that in 2008?
Your answer should be very brief. 0.6. What is the ratio of the Value added (in %) of Slovak Republic in 2005 to that in 2008?
Make the answer very short. 1.09. What is the ratio of the Value added (in %) in South Africa in 2005 to that in 2008?
Provide a succinct answer. 0.98. What is the ratio of the Value added (in %) in Uruguay in 2005 to that in 2008?
Provide a short and direct response. 1.14. What is the ratio of the Value added (in %) of Denmark in 2005 to that in 2009?
Your answer should be very brief. 1.28. What is the ratio of the Value added (in %) of Slovak Republic in 2005 to that in 2009?
Ensure brevity in your answer.  1.33. What is the ratio of the Value added (in %) in South Africa in 2005 to that in 2009?
Offer a terse response. 1.02. What is the ratio of the Value added (in %) of Uruguay in 2005 to that in 2009?
Ensure brevity in your answer.  1.04. What is the ratio of the Value added (in %) in Denmark in 2007 to that in 2008?
Offer a very short reply. 0.64. What is the ratio of the Value added (in %) of Slovak Republic in 2007 to that in 2008?
Provide a succinct answer. 0.97. What is the ratio of the Value added (in %) in South Africa in 2007 to that in 2008?
Keep it short and to the point. 0.99. What is the ratio of the Value added (in %) in Uruguay in 2007 to that in 2008?
Your answer should be very brief. 1.16. What is the ratio of the Value added (in %) in Denmark in 2007 to that in 2009?
Make the answer very short. 1.36. What is the ratio of the Value added (in %) of Slovak Republic in 2007 to that in 2009?
Provide a short and direct response. 1.18. What is the ratio of the Value added (in %) in South Africa in 2007 to that in 2009?
Offer a terse response. 1.03. What is the ratio of the Value added (in %) in Uruguay in 2007 to that in 2009?
Provide a succinct answer. 1.06. What is the ratio of the Value added (in %) of Denmark in 2008 to that in 2009?
Ensure brevity in your answer.  2.12. What is the ratio of the Value added (in %) of Slovak Republic in 2008 to that in 2009?
Your response must be concise. 1.22. What is the ratio of the Value added (in %) in South Africa in 2008 to that in 2009?
Ensure brevity in your answer.  1.04. What is the ratio of the Value added (in %) in Uruguay in 2008 to that in 2009?
Your answer should be very brief. 0.91. What is the difference between the highest and the second highest Value added (in %) of Denmark?
Your answer should be compact. 28.39. What is the difference between the highest and the second highest Value added (in %) of Slovak Republic?
Your answer should be compact. 0.86. What is the difference between the highest and the second highest Value added (in %) in South Africa?
Ensure brevity in your answer.  0.35. What is the difference between the highest and the second highest Value added (in %) in Uruguay?
Provide a succinct answer. 1.12. What is the difference between the highest and the lowest Value added (in %) in Denmark?
Give a very brief answer. 41.93. What is the difference between the highest and the lowest Value added (in %) in Slovak Republic?
Offer a terse response. 15.54. What is the difference between the highest and the lowest Value added (in %) of South Africa?
Your response must be concise. 2.68. What is the difference between the highest and the lowest Value added (in %) in Uruguay?
Offer a very short reply. 7.46. 